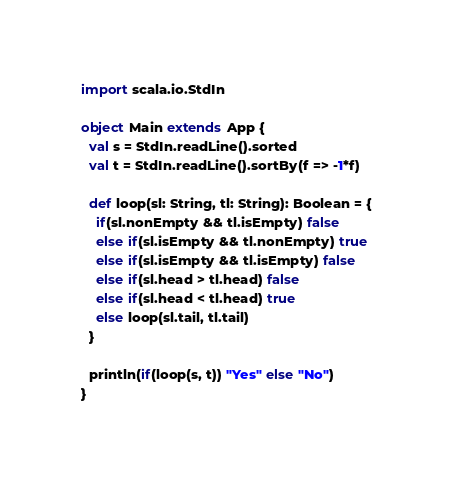<code> <loc_0><loc_0><loc_500><loc_500><_Scala_>import scala.io.StdIn

object Main extends App {
  val s = StdIn.readLine().sorted
  val t = StdIn.readLine().sortBy(f => -1*f)
  
  def loop(sl: String, tl: String): Boolean = {
    if(sl.nonEmpty && tl.isEmpty) false
    else if(sl.isEmpty && tl.nonEmpty) true
    else if(sl.isEmpty && tl.isEmpty) false
    else if(sl.head > tl.head) false
    else if(sl.head < tl.head) true
    else loop(sl.tail, tl.tail)
  }
  
  println(if(loop(s, t)) "Yes" else "No")
}
</code> 